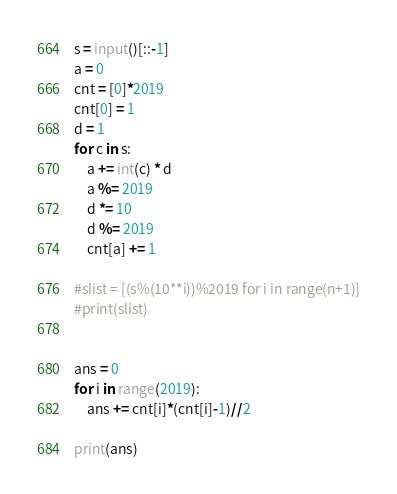Convert code to text. <code><loc_0><loc_0><loc_500><loc_500><_Python_>s = input()[::-1]
a = 0
cnt = [0]*2019
cnt[0] = 1
d = 1
for c in s:
    a += int(c) * d
    a %= 2019
    d *= 10
    d %= 2019
    cnt[a] += 1

#slist = [(s%(10**i))%2019 for i in range(n+1)]
#print(slist)


ans = 0
for i in range(2019):
    ans += cnt[i]*(cnt[i]-1)//2

print(ans)
</code> 